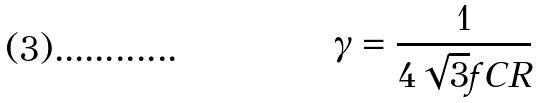Convert formula to latex. <formula><loc_0><loc_0><loc_500><loc_500>\gamma = \frac { 1 } { 4 \sqrt { 3 } f C R }</formula> 